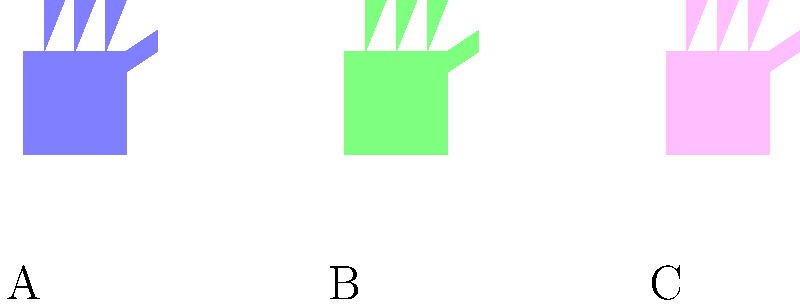In crisis negotiations, understanding cultural gestures is crucial. Which of the hand signals shown above (A, B, or C) represents the "OK" gesture in Western cultures but could be considered offensive in some Middle Eastern countries? To answer this question, we need to analyze the three hand gestures presented and understand their cultural significance:

1. Gesture A (Blue): This appears to be an open palm, which is generally a universal sign for "stop" or "halt". It's not typically offensive in most cultures.

2. Gesture B (Green): This shows a hand forming a circle with the thumb and index finger, while the other fingers are extended. This is the gesture we're looking for.
   - In Western cultures, this gesture typically means "OK" or "perfect".
   - However, in some Middle Eastern countries, particularly in Turkey and parts of the Arab world, this same gesture can be considered offensive or vulgar, similar to giving the middle finger in Western cultures.

3. Gesture C (Pink): This seems to be a closed fist, which can have various meanings depending on the context and culture, but it doesn't match our description.

The gesture that fits the description in the question is Gesture B (Green). It's a prime example of how the same hand signal can have drastically different interpretations across cultures, which is crucial knowledge for an international crisis negotiator.
Answer: B 